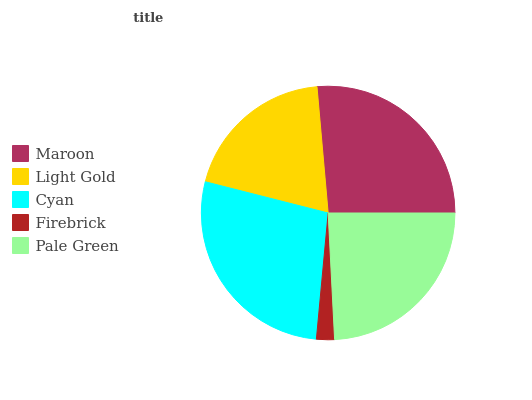Is Firebrick the minimum?
Answer yes or no. Yes. Is Cyan the maximum?
Answer yes or no. Yes. Is Light Gold the minimum?
Answer yes or no. No. Is Light Gold the maximum?
Answer yes or no. No. Is Maroon greater than Light Gold?
Answer yes or no. Yes. Is Light Gold less than Maroon?
Answer yes or no. Yes. Is Light Gold greater than Maroon?
Answer yes or no. No. Is Maroon less than Light Gold?
Answer yes or no. No. Is Pale Green the high median?
Answer yes or no. Yes. Is Pale Green the low median?
Answer yes or no. Yes. Is Firebrick the high median?
Answer yes or no. No. Is Maroon the low median?
Answer yes or no. No. 